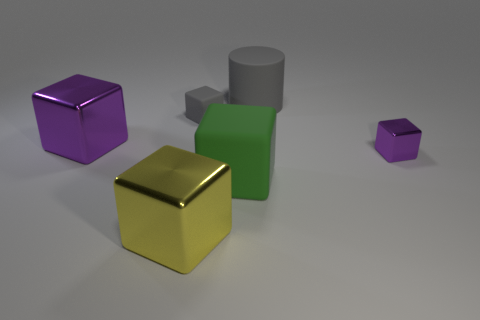How many things are gray matte objects to the left of the large cylinder or tiny cyan rubber cubes?
Provide a short and direct response. 1. Is the number of large green matte cubes that are behind the tiny gray cube the same as the number of cubes that are in front of the large purple cube?
Keep it short and to the point. No. There is a purple object that is in front of the purple object that is left of the green matte thing to the left of the large rubber cylinder; what is it made of?
Your answer should be compact. Metal. How big is the matte thing that is to the right of the tiny gray matte block and in front of the large gray rubber cylinder?
Offer a very short reply. Large. Do the large green object and the big yellow metallic thing have the same shape?
Your answer should be compact. Yes. What shape is the small object that is the same material as the large gray cylinder?
Provide a short and direct response. Cube. What number of tiny things are purple blocks or shiny balls?
Provide a succinct answer. 1. Is there a small purple metallic object that is on the right side of the large object that is behind the small matte cube?
Offer a very short reply. Yes. Are any gray cylinders visible?
Give a very brief answer. Yes. What is the color of the matte object that is on the right side of the large matte object that is in front of the small purple metallic cube?
Make the answer very short. Gray. 